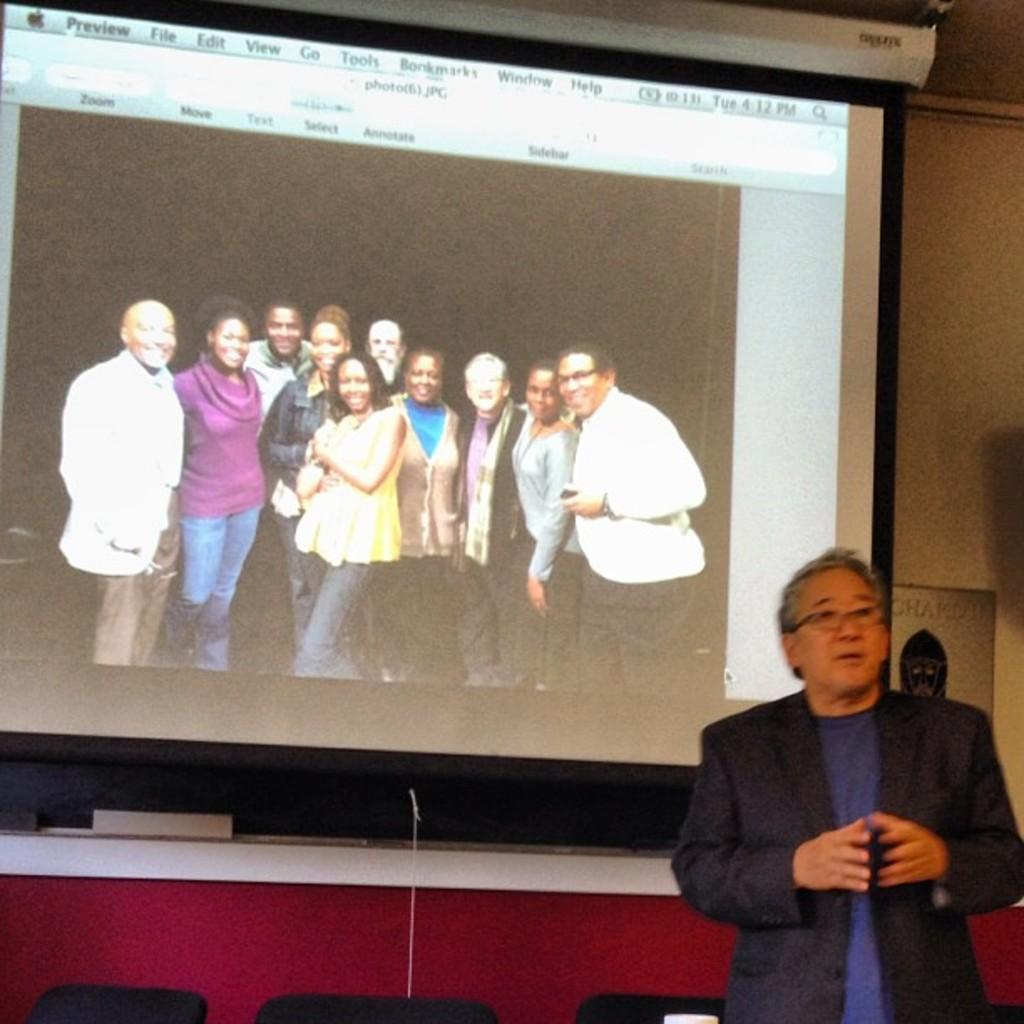Could you give a brief overview of what you see in this image? On the right side a man is standing, he wore coat, t-shirt. In the middle it is a projected image. In this a group of people are standing and smiling. 